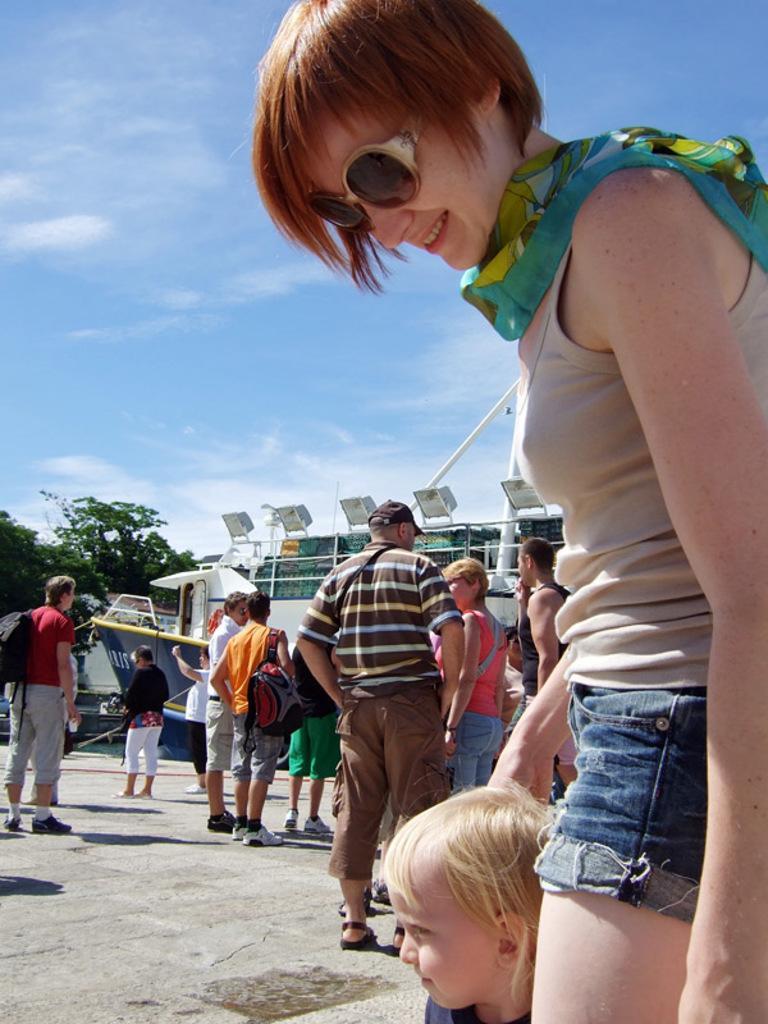In one or two sentences, can you explain what this image depicts? In the foreground, I can see a crowd on the road. In the background, I can see buildings, lights, trees, vehicles and the sky. This image taken, maybe during a day. 